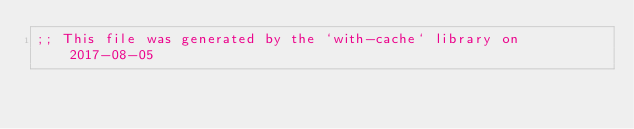Convert code to text. <code><loc_0><loc_0><loc_500><loc_500><_Racket_>;; This file was generated by the `with-cache` library on 2017-08-05</code> 